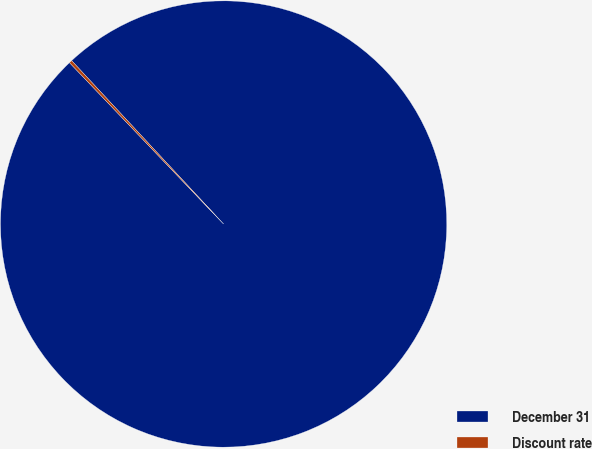Convert chart. <chart><loc_0><loc_0><loc_500><loc_500><pie_chart><fcel>December 31<fcel>Discount rate<nl><fcel>99.79%<fcel>0.21%<nl></chart> 